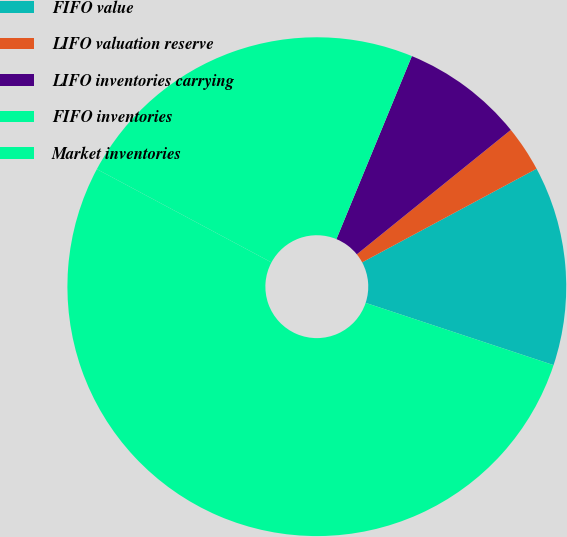Convert chart to OTSL. <chart><loc_0><loc_0><loc_500><loc_500><pie_chart><fcel>FIFO value<fcel>LIFO valuation reserve<fcel>LIFO inventories carrying<fcel>FIFO inventories<fcel>Market inventories<nl><fcel>12.93%<fcel>2.98%<fcel>7.96%<fcel>23.41%<fcel>52.72%<nl></chart> 